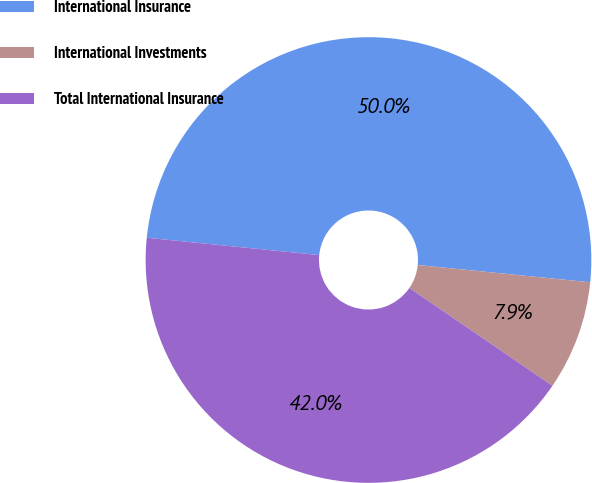Convert chart. <chart><loc_0><loc_0><loc_500><loc_500><pie_chart><fcel>International Insurance<fcel>International Investments<fcel>Total International Insurance<nl><fcel>50.0%<fcel>7.95%<fcel>42.05%<nl></chart> 